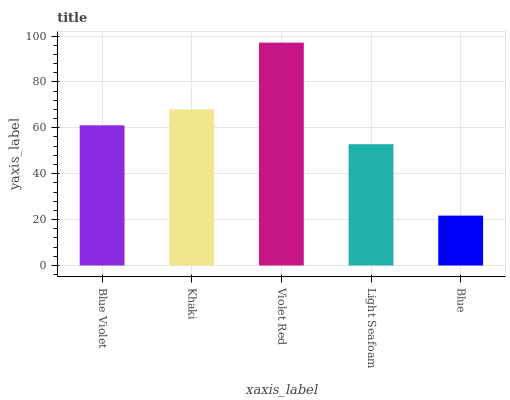Is Blue the minimum?
Answer yes or no. Yes. Is Violet Red the maximum?
Answer yes or no. Yes. Is Khaki the minimum?
Answer yes or no. No. Is Khaki the maximum?
Answer yes or no. No. Is Khaki greater than Blue Violet?
Answer yes or no. Yes. Is Blue Violet less than Khaki?
Answer yes or no. Yes. Is Blue Violet greater than Khaki?
Answer yes or no. No. Is Khaki less than Blue Violet?
Answer yes or no. No. Is Blue Violet the high median?
Answer yes or no. Yes. Is Blue Violet the low median?
Answer yes or no. Yes. Is Light Seafoam the high median?
Answer yes or no. No. Is Light Seafoam the low median?
Answer yes or no. No. 